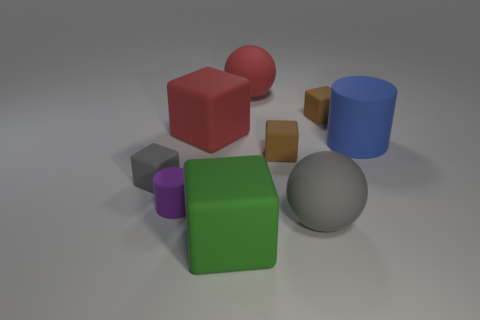Subtract all small gray cubes. How many cubes are left? 4 Subtract all cyan cylinders. How many brown blocks are left? 2 Subtract all brown blocks. How many blocks are left? 3 Subtract 2 cubes. How many cubes are left? 3 Subtract all brown blocks. Subtract all brown balls. How many blocks are left? 3 Add 1 large blue cylinders. How many objects exist? 10 Subtract all cubes. How many objects are left? 4 Subtract 0 brown cylinders. How many objects are left? 9 Subtract all big yellow metal cubes. Subtract all blocks. How many objects are left? 4 Add 6 red matte things. How many red matte things are left? 8 